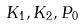Convert formula to latex. <formula><loc_0><loc_0><loc_500><loc_500>K _ { 1 } , K _ { 2 } , P _ { 0 }</formula> 